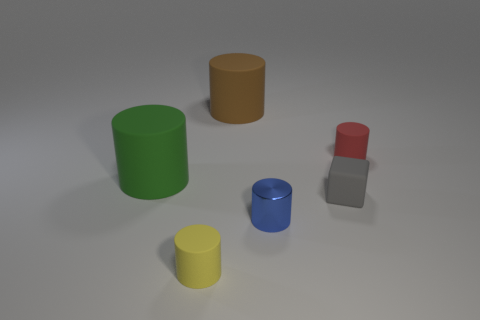Subtract all large cylinders. How many cylinders are left? 3 Add 3 cyan rubber cylinders. How many objects exist? 9 Subtract all yellow cylinders. How many cylinders are left? 4 Add 3 large brown rubber objects. How many large brown rubber objects exist? 4 Subtract 0 purple spheres. How many objects are left? 6 Subtract all cubes. How many objects are left? 5 Subtract all blue cylinders. Subtract all blue cubes. How many cylinders are left? 4 Subtract all brown metal spheres. Subtract all yellow cylinders. How many objects are left? 5 Add 6 small rubber cylinders. How many small rubber cylinders are left? 8 